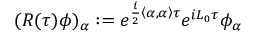<formula> <loc_0><loc_0><loc_500><loc_500>( R ( \tau ) \phi ) _ { \alpha } \colon = e ^ { \frac { i } { 2 } \left \langle \alpha , \alpha \right \rangle \tau } e ^ { i L _ { 0 } \tau } \phi _ { \alpha }</formula> 